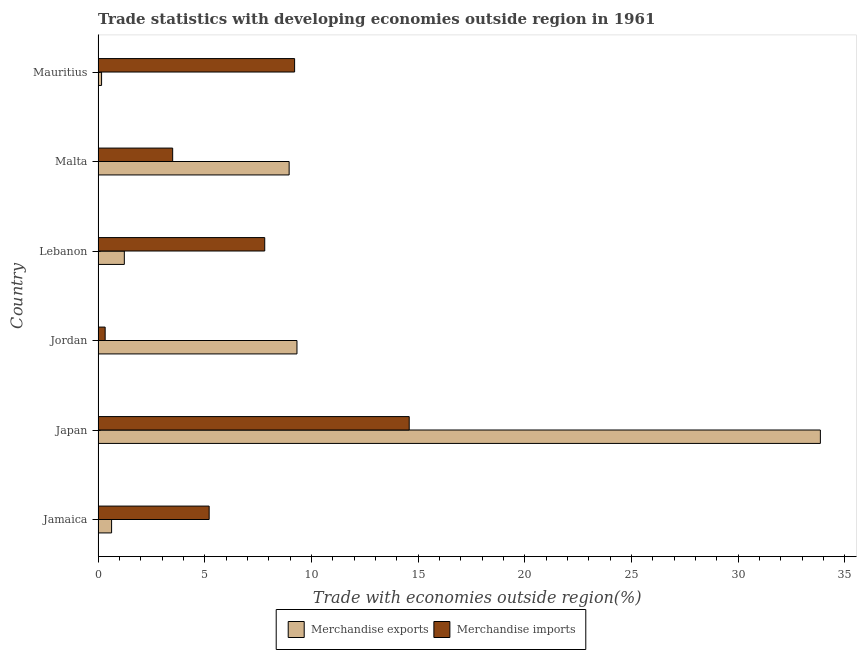Are the number of bars per tick equal to the number of legend labels?
Your answer should be very brief. Yes. How many bars are there on the 4th tick from the bottom?
Your answer should be very brief. 2. What is the label of the 4th group of bars from the top?
Ensure brevity in your answer.  Jordan. What is the merchandise imports in Mauritius?
Provide a succinct answer. 9.21. Across all countries, what is the maximum merchandise exports?
Offer a very short reply. 33.85. Across all countries, what is the minimum merchandise imports?
Ensure brevity in your answer.  0.33. In which country was the merchandise exports minimum?
Provide a short and direct response. Mauritius. What is the total merchandise exports in the graph?
Offer a very short reply. 54.16. What is the difference between the merchandise exports in Jamaica and that in Japan?
Your answer should be very brief. -33.22. What is the difference between the merchandise imports in Japan and the merchandise exports in Lebanon?
Offer a terse response. 13.35. What is the average merchandise imports per country?
Give a very brief answer. 6.77. What is the difference between the merchandise imports and merchandise exports in Jordan?
Provide a short and direct response. -8.99. What is the ratio of the merchandise exports in Jamaica to that in Lebanon?
Your answer should be compact. 0.52. Is the merchandise exports in Malta less than that in Mauritius?
Offer a very short reply. No. What is the difference between the highest and the second highest merchandise imports?
Provide a short and direct response. 5.37. What is the difference between the highest and the lowest merchandise imports?
Your answer should be very brief. 14.25. What does the 1st bar from the top in Mauritius represents?
Give a very brief answer. Merchandise imports. How many bars are there?
Make the answer very short. 12. Are the values on the major ticks of X-axis written in scientific E-notation?
Your answer should be very brief. No. Does the graph contain grids?
Your answer should be very brief. No. Where does the legend appear in the graph?
Make the answer very short. Bottom center. How many legend labels are there?
Offer a terse response. 2. How are the legend labels stacked?
Give a very brief answer. Horizontal. What is the title of the graph?
Your answer should be very brief. Trade statistics with developing economies outside region in 1961. Does "Travel Items" appear as one of the legend labels in the graph?
Provide a succinct answer. No. What is the label or title of the X-axis?
Provide a succinct answer. Trade with economies outside region(%). What is the label or title of the Y-axis?
Offer a very short reply. Country. What is the Trade with economies outside region(%) of Merchandise exports in Jamaica?
Provide a short and direct response. 0.63. What is the Trade with economies outside region(%) in Merchandise imports in Jamaica?
Offer a terse response. 5.21. What is the Trade with economies outside region(%) in Merchandise exports in Japan?
Make the answer very short. 33.85. What is the Trade with economies outside region(%) of Merchandise imports in Japan?
Provide a succinct answer. 14.58. What is the Trade with economies outside region(%) of Merchandise exports in Jordan?
Provide a short and direct response. 9.32. What is the Trade with economies outside region(%) of Merchandise imports in Jordan?
Your response must be concise. 0.33. What is the Trade with economies outside region(%) in Merchandise exports in Lebanon?
Provide a succinct answer. 1.23. What is the Trade with economies outside region(%) in Merchandise imports in Lebanon?
Ensure brevity in your answer.  7.81. What is the Trade with economies outside region(%) of Merchandise exports in Malta?
Keep it short and to the point. 8.96. What is the Trade with economies outside region(%) in Merchandise imports in Malta?
Give a very brief answer. 3.5. What is the Trade with economies outside region(%) of Merchandise exports in Mauritius?
Offer a very short reply. 0.17. What is the Trade with economies outside region(%) of Merchandise imports in Mauritius?
Provide a short and direct response. 9.21. Across all countries, what is the maximum Trade with economies outside region(%) in Merchandise exports?
Ensure brevity in your answer.  33.85. Across all countries, what is the maximum Trade with economies outside region(%) of Merchandise imports?
Offer a very short reply. 14.58. Across all countries, what is the minimum Trade with economies outside region(%) in Merchandise exports?
Provide a succinct answer. 0.17. Across all countries, what is the minimum Trade with economies outside region(%) of Merchandise imports?
Offer a very short reply. 0.33. What is the total Trade with economies outside region(%) in Merchandise exports in the graph?
Give a very brief answer. 54.16. What is the total Trade with economies outside region(%) in Merchandise imports in the graph?
Make the answer very short. 40.64. What is the difference between the Trade with economies outside region(%) of Merchandise exports in Jamaica and that in Japan?
Offer a very short reply. -33.22. What is the difference between the Trade with economies outside region(%) of Merchandise imports in Jamaica and that in Japan?
Offer a terse response. -9.38. What is the difference between the Trade with economies outside region(%) in Merchandise exports in Jamaica and that in Jordan?
Make the answer very short. -8.69. What is the difference between the Trade with economies outside region(%) in Merchandise imports in Jamaica and that in Jordan?
Provide a succinct answer. 4.87. What is the difference between the Trade with economies outside region(%) of Merchandise exports in Jamaica and that in Lebanon?
Your answer should be very brief. -0.6. What is the difference between the Trade with economies outside region(%) in Merchandise imports in Jamaica and that in Lebanon?
Your response must be concise. -2.6. What is the difference between the Trade with economies outside region(%) of Merchandise exports in Jamaica and that in Malta?
Give a very brief answer. -8.32. What is the difference between the Trade with economies outside region(%) in Merchandise imports in Jamaica and that in Malta?
Offer a terse response. 1.71. What is the difference between the Trade with economies outside region(%) of Merchandise exports in Jamaica and that in Mauritius?
Make the answer very short. 0.47. What is the difference between the Trade with economies outside region(%) of Merchandise imports in Jamaica and that in Mauritius?
Provide a succinct answer. -4. What is the difference between the Trade with economies outside region(%) of Merchandise exports in Japan and that in Jordan?
Offer a very short reply. 24.53. What is the difference between the Trade with economies outside region(%) in Merchandise imports in Japan and that in Jordan?
Your answer should be compact. 14.25. What is the difference between the Trade with economies outside region(%) of Merchandise exports in Japan and that in Lebanon?
Keep it short and to the point. 32.62. What is the difference between the Trade with economies outside region(%) in Merchandise imports in Japan and that in Lebanon?
Ensure brevity in your answer.  6.77. What is the difference between the Trade with economies outside region(%) of Merchandise exports in Japan and that in Malta?
Your response must be concise. 24.9. What is the difference between the Trade with economies outside region(%) in Merchandise imports in Japan and that in Malta?
Offer a very short reply. 11.09. What is the difference between the Trade with economies outside region(%) of Merchandise exports in Japan and that in Mauritius?
Your answer should be very brief. 33.68. What is the difference between the Trade with economies outside region(%) of Merchandise imports in Japan and that in Mauritius?
Ensure brevity in your answer.  5.37. What is the difference between the Trade with economies outside region(%) of Merchandise exports in Jordan and that in Lebanon?
Make the answer very short. 8.09. What is the difference between the Trade with economies outside region(%) of Merchandise imports in Jordan and that in Lebanon?
Give a very brief answer. -7.48. What is the difference between the Trade with economies outside region(%) in Merchandise exports in Jordan and that in Malta?
Make the answer very short. 0.37. What is the difference between the Trade with economies outside region(%) in Merchandise imports in Jordan and that in Malta?
Make the answer very short. -3.16. What is the difference between the Trade with economies outside region(%) in Merchandise exports in Jordan and that in Mauritius?
Offer a terse response. 9.16. What is the difference between the Trade with economies outside region(%) in Merchandise imports in Jordan and that in Mauritius?
Your response must be concise. -8.88. What is the difference between the Trade with economies outside region(%) of Merchandise exports in Lebanon and that in Malta?
Provide a short and direct response. -7.72. What is the difference between the Trade with economies outside region(%) of Merchandise imports in Lebanon and that in Malta?
Ensure brevity in your answer.  4.31. What is the difference between the Trade with economies outside region(%) of Merchandise exports in Lebanon and that in Mauritius?
Your response must be concise. 1.07. What is the difference between the Trade with economies outside region(%) in Merchandise imports in Lebanon and that in Mauritius?
Your response must be concise. -1.4. What is the difference between the Trade with economies outside region(%) in Merchandise exports in Malta and that in Mauritius?
Provide a short and direct response. 8.79. What is the difference between the Trade with economies outside region(%) of Merchandise imports in Malta and that in Mauritius?
Give a very brief answer. -5.71. What is the difference between the Trade with economies outside region(%) in Merchandise exports in Jamaica and the Trade with economies outside region(%) in Merchandise imports in Japan?
Keep it short and to the point. -13.95. What is the difference between the Trade with economies outside region(%) in Merchandise exports in Jamaica and the Trade with economies outside region(%) in Merchandise imports in Jordan?
Your answer should be very brief. 0.3. What is the difference between the Trade with economies outside region(%) in Merchandise exports in Jamaica and the Trade with economies outside region(%) in Merchandise imports in Lebanon?
Provide a short and direct response. -7.18. What is the difference between the Trade with economies outside region(%) of Merchandise exports in Jamaica and the Trade with economies outside region(%) of Merchandise imports in Malta?
Offer a very short reply. -2.86. What is the difference between the Trade with economies outside region(%) in Merchandise exports in Jamaica and the Trade with economies outside region(%) in Merchandise imports in Mauritius?
Your response must be concise. -8.58. What is the difference between the Trade with economies outside region(%) of Merchandise exports in Japan and the Trade with economies outside region(%) of Merchandise imports in Jordan?
Make the answer very short. 33.52. What is the difference between the Trade with economies outside region(%) of Merchandise exports in Japan and the Trade with economies outside region(%) of Merchandise imports in Lebanon?
Your response must be concise. 26.04. What is the difference between the Trade with economies outside region(%) in Merchandise exports in Japan and the Trade with economies outside region(%) in Merchandise imports in Malta?
Give a very brief answer. 30.35. What is the difference between the Trade with economies outside region(%) of Merchandise exports in Japan and the Trade with economies outside region(%) of Merchandise imports in Mauritius?
Offer a terse response. 24.64. What is the difference between the Trade with economies outside region(%) of Merchandise exports in Jordan and the Trade with economies outside region(%) of Merchandise imports in Lebanon?
Make the answer very short. 1.51. What is the difference between the Trade with economies outside region(%) of Merchandise exports in Jordan and the Trade with economies outside region(%) of Merchandise imports in Malta?
Offer a terse response. 5.83. What is the difference between the Trade with economies outside region(%) in Merchandise exports in Jordan and the Trade with economies outside region(%) in Merchandise imports in Mauritius?
Your answer should be compact. 0.11. What is the difference between the Trade with economies outside region(%) of Merchandise exports in Lebanon and the Trade with economies outside region(%) of Merchandise imports in Malta?
Your response must be concise. -2.27. What is the difference between the Trade with economies outside region(%) of Merchandise exports in Lebanon and the Trade with economies outside region(%) of Merchandise imports in Mauritius?
Your answer should be very brief. -7.98. What is the difference between the Trade with economies outside region(%) in Merchandise exports in Malta and the Trade with economies outside region(%) in Merchandise imports in Mauritius?
Make the answer very short. -0.26. What is the average Trade with economies outside region(%) of Merchandise exports per country?
Your answer should be very brief. 9.03. What is the average Trade with economies outside region(%) in Merchandise imports per country?
Your answer should be very brief. 6.77. What is the difference between the Trade with economies outside region(%) of Merchandise exports and Trade with economies outside region(%) of Merchandise imports in Jamaica?
Provide a short and direct response. -4.57. What is the difference between the Trade with economies outside region(%) in Merchandise exports and Trade with economies outside region(%) in Merchandise imports in Japan?
Offer a terse response. 19.27. What is the difference between the Trade with economies outside region(%) of Merchandise exports and Trade with economies outside region(%) of Merchandise imports in Jordan?
Offer a very short reply. 8.99. What is the difference between the Trade with economies outside region(%) in Merchandise exports and Trade with economies outside region(%) in Merchandise imports in Lebanon?
Ensure brevity in your answer.  -6.58. What is the difference between the Trade with economies outside region(%) in Merchandise exports and Trade with economies outside region(%) in Merchandise imports in Malta?
Your answer should be very brief. 5.46. What is the difference between the Trade with economies outside region(%) of Merchandise exports and Trade with economies outside region(%) of Merchandise imports in Mauritius?
Your answer should be very brief. -9.05. What is the ratio of the Trade with economies outside region(%) of Merchandise exports in Jamaica to that in Japan?
Provide a short and direct response. 0.02. What is the ratio of the Trade with economies outside region(%) in Merchandise imports in Jamaica to that in Japan?
Give a very brief answer. 0.36. What is the ratio of the Trade with economies outside region(%) of Merchandise exports in Jamaica to that in Jordan?
Offer a terse response. 0.07. What is the ratio of the Trade with economies outside region(%) of Merchandise imports in Jamaica to that in Jordan?
Provide a succinct answer. 15.65. What is the ratio of the Trade with economies outside region(%) in Merchandise exports in Jamaica to that in Lebanon?
Provide a succinct answer. 0.52. What is the ratio of the Trade with economies outside region(%) in Merchandise imports in Jamaica to that in Lebanon?
Provide a short and direct response. 0.67. What is the ratio of the Trade with economies outside region(%) of Merchandise exports in Jamaica to that in Malta?
Offer a terse response. 0.07. What is the ratio of the Trade with economies outside region(%) of Merchandise imports in Jamaica to that in Malta?
Ensure brevity in your answer.  1.49. What is the ratio of the Trade with economies outside region(%) in Merchandise exports in Jamaica to that in Mauritius?
Ensure brevity in your answer.  3.83. What is the ratio of the Trade with economies outside region(%) in Merchandise imports in Jamaica to that in Mauritius?
Your answer should be very brief. 0.57. What is the ratio of the Trade with economies outside region(%) in Merchandise exports in Japan to that in Jordan?
Keep it short and to the point. 3.63. What is the ratio of the Trade with economies outside region(%) in Merchandise imports in Japan to that in Jordan?
Keep it short and to the point. 43.83. What is the ratio of the Trade with economies outside region(%) of Merchandise exports in Japan to that in Lebanon?
Offer a terse response. 27.49. What is the ratio of the Trade with economies outside region(%) of Merchandise imports in Japan to that in Lebanon?
Your answer should be very brief. 1.87. What is the ratio of the Trade with economies outside region(%) in Merchandise exports in Japan to that in Malta?
Offer a terse response. 3.78. What is the ratio of the Trade with economies outside region(%) in Merchandise imports in Japan to that in Malta?
Your answer should be compact. 4.17. What is the ratio of the Trade with economies outside region(%) in Merchandise exports in Japan to that in Mauritius?
Ensure brevity in your answer.  204.46. What is the ratio of the Trade with economies outside region(%) of Merchandise imports in Japan to that in Mauritius?
Offer a terse response. 1.58. What is the ratio of the Trade with economies outside region(%) in Merchandise exports in Jordan to that in Lebanon?
Give a very brief answer. 7.57. What is the ratio of the Trade with economies outside region(%) of Merchandise imports in Jordan to that in Lebanon?
Give a very brief answer. 0.04. What is the ratio of the Trade with economies outside region(%) in Merchandise exports in Jordan to that in Malta?
Ensure brevity in your answer.  1.04. What is the ratio of the Trade with economies outside region(%) of Merchandise imports in Jordan to that in Malta?
Your answer should be very brief. 0.1. What is the ratio of the Trade with economies outside region(%) of Merchandise exports in Jordan to that in Mauritius?
Provide a succinct answer. 56.31. What is the ratio of the Trade with economies outside region(%) in Merchandise imports in Jordan to that in Mauritius?
Ensure brevity in your answer.  0.04. What is the ratio of the Trade with economies outside region(%) in Merchandise exports in Lebanon to that in Malta?
Make the answer very short. 0.14. What is the ratio of the Trade with economies outside region(%) of Merchandise imports in Lebanon to that in Malta?
Provide a succinct answer. 2.23. What is the ratio of the Trade with economies outside region(%) of Merchandise exports in Lebanon to that in Mauritius?
Offer a terse response. 7.44. What is the ratio of the Trade with economies outside region(%) in Merchandise imports in Lebanon to that in Mauritius?
Your answer should be compact. 0.85. What is the ratio of the Trade with economies outside region(%) in Merchandise exports in Malta to that in Mauritius?
Your answer should be very brief. 54.09. What is the ratio of the Trade with economies outside region(%) of Merchandise imports in Malta to that in Mauritius?
Provide a succinct answer. 0.38. What is the difference between the highest and the second highest Trade with economies outside region(%) in Merchandise exports?
Your answer should be very brief. 24.53. What is the difference between the highest and the second highest Trade with economies outside region(%) of Merchandise imports?
Your response must be concise. 5.37. What is the difference between the highest and the lowest Trade with economies outside region(%) in Merchandise exports?
Give a very brief answer. 33.68. What is the difference between the highest and the lowest Trade with economies outside region(%) of Merchandise imports?
Offer a terse response. 14.25. 